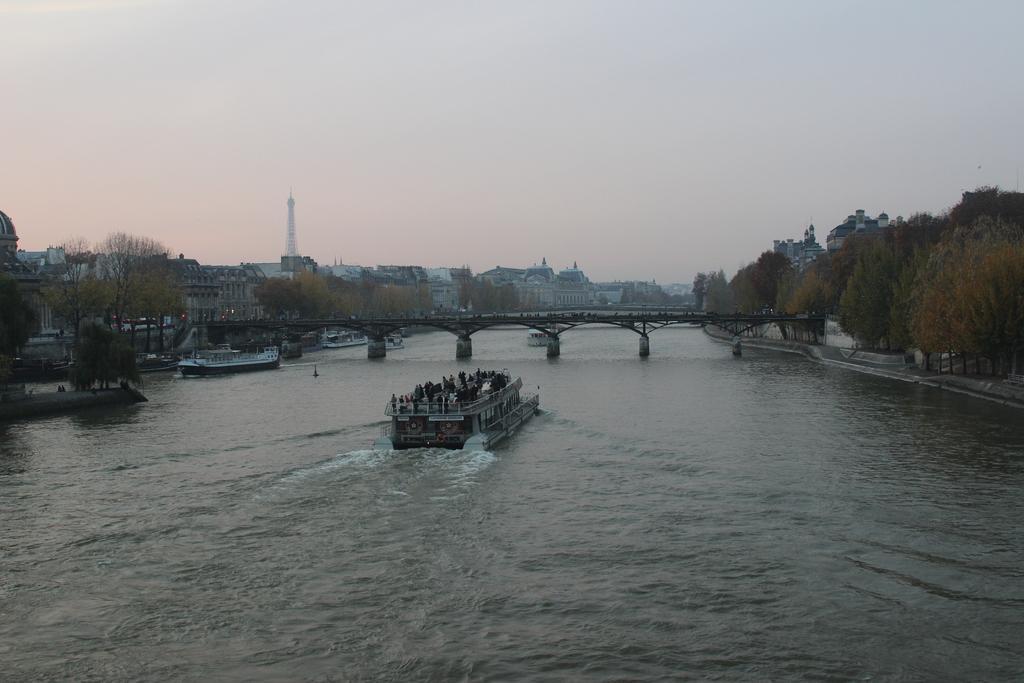Please provide a concise description of this image. In the foreground of this image, there is a boat on the water. In the background, there are trees, a bridge, another ship on the water, few buildings, a tower and the sky. 